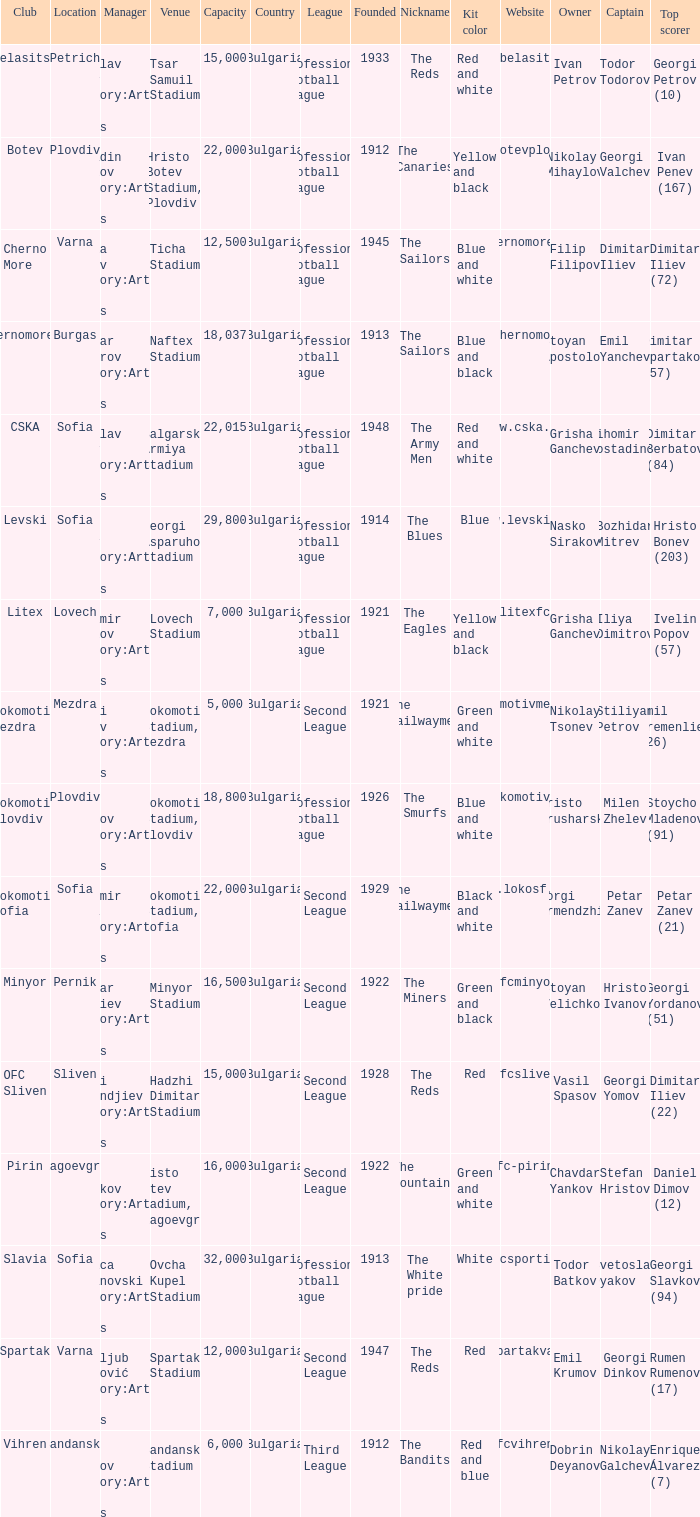What is the total number of capacity for the venue of the club, pirin? 1.0. 